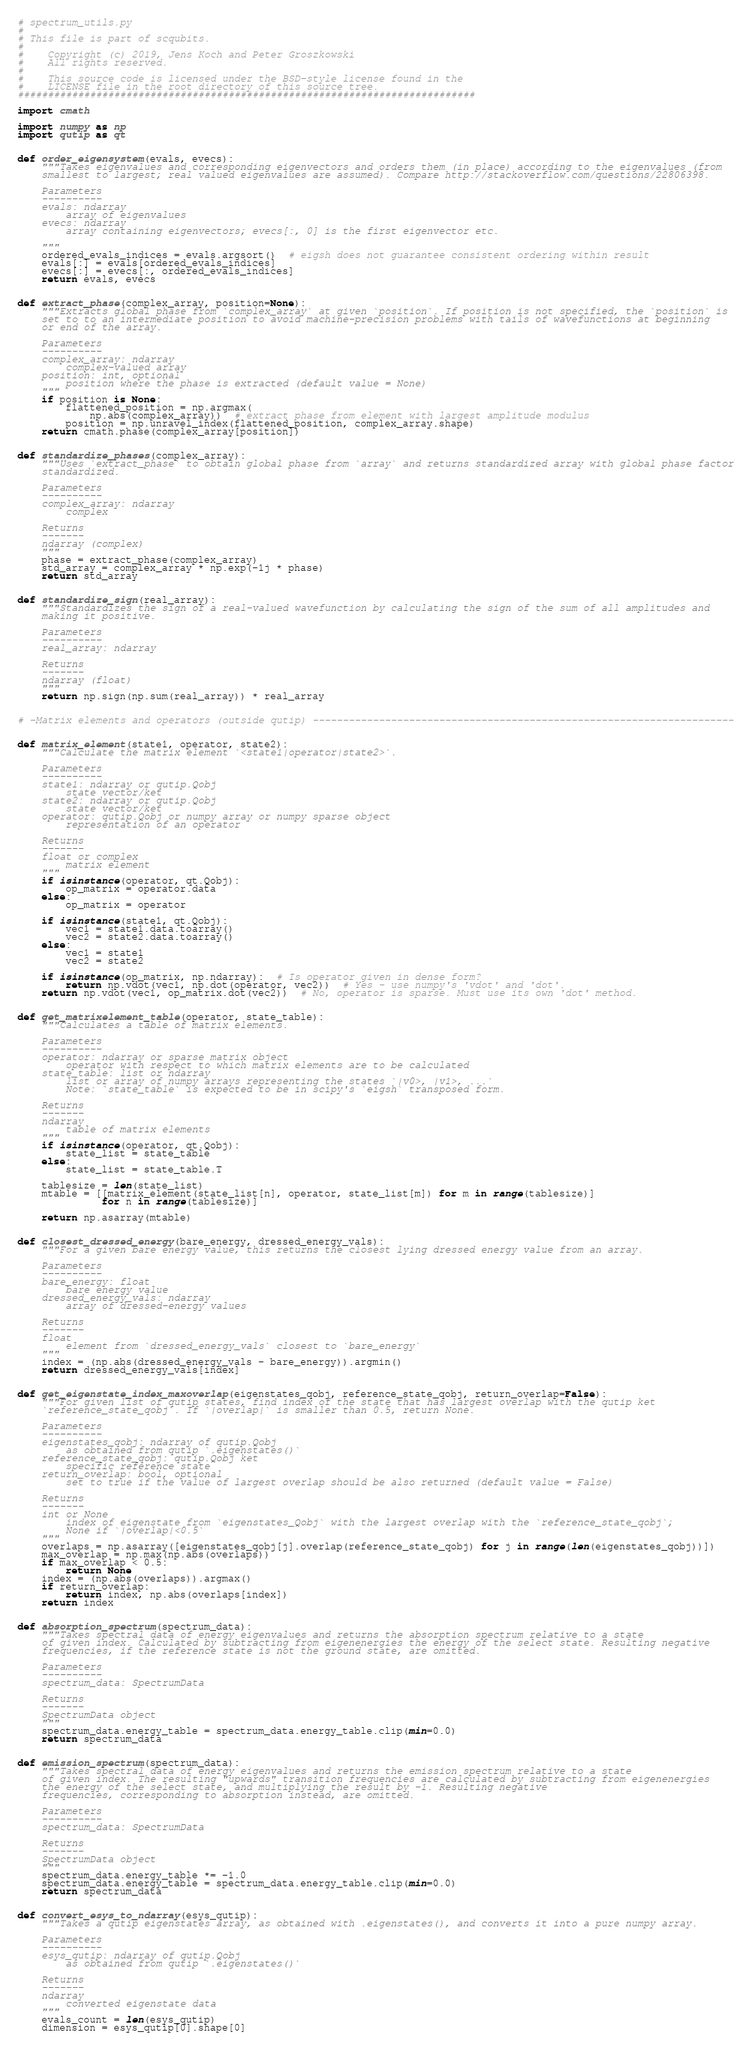<code> <loc_0><loc_0><loc_500><loc_500><_Python_># spectrum_utils.py
#
# This file is part of scqubits.
#
#    Copyright (c) 2019, Jens Koch and Peter Groszkowski
#    All rights reserved.
#
#    This source code is licensed under the BSD-style license found in the
#    LICENSE file in the root directory of this source tree.
############################################################################

import cmath

import numpy as np
import qutip as qt


def order_eigensystem(evals, evecs):
    """Takes eigenvalues and corresponding eigenvectors and orders them (in place) according to the eigenvalues (from
    smallest to largest; real valued eigenvalues are assumed). Compare http://stackoverflow.com/questions/22806398.

    Parameters
    ----------
    evals: ndarray
        array of eigenvalues
    evecs: ndarray
        array containing eigenvectors; evecs[:, 0] is the first eigenvector etc.

    """
    ordered_evals_indices = evals.argsort()  # eigsh does not guarantee consistent ordering within result
    evals[:] = evals[ordered_evals_indices]
    evecs[:] = evecs[:, ordered_evals_indices]
    return evals, evecs


def extract_phase(complex_array, position=None):
    """Extracts global phase from `complex_array` at given `position`. If position is not specified, the `position` is
    set to to an intermediate position to avoid machine-precision problems with tails of wavefunctions at beginning
    or end of the array.

    Parameters
    ----------
    complex_array: ndarray
        complex-valued array
    position: int, optional
        position where the phase is extracted (default value = None)
    """
    if position is None:
        flattened_position = np.argmax(
            np.abs(complex_array))  # extract phase from element with largest amplitude modulus
        position = np.unravel_index(flattened_position, complex_array.shape)
    return cmath.phase(complex_array[position])


def standardize_phases(complex_array):
    """Uses `extract_phase` to obtain global phase from `array` and returns standardized array with global phase factor
    standardized.

    Parameters
    ----------
    complex_array: ndarray
        complex

    Returns
    -------
    ndarray (complex)
    """
    phase = extract_phase(complex_array)
    std_array = complex_array * np.exp(-1j * phase)
    return std_array


def standardize_sign(real_array):
    """Standardizes the sign of a real-valued wavefunction by calculating the sign of the sum of all amplitudes and
    making it positive.

    Parameters
    ----------
    real_array: ndarray

    Returns
    -------
    ndarray (float)
    """
    return np.sign(np.sum(real_array)) * real_array


# -Matrix elements and operators (outside qutip) ----------------------------------------------------------------------


def matrix_element(state1, operator, state2):
    """Calculate the matrix element `<state1|operator|state2>`.

    Parameters
    ----------
    state1: ndarray or qutip.Qobj
        state vector/ket
    state2: ndarray or qutip.Qobj
        state vector/ket
    operator: qutip.Qobj or numpy array or numpy sparse object
        representation of an operator

    Returns
    -------
    float or complex
        matrix element
    """
    if isinstance(operator, qt.Qobj):
        op_matrix = operator.data
    else:
        op_matrix = operator

    if isinstance(state1, qt.Qobj):
        vec1 = state1.data.toarray()
        vec2 = state2.data.toarray()
    else:
        vec1 = state1
        vec2 = state2

    if isinstance(op_matrix, np.ndarray):  # Is operator given in dense form?
        return np.vdot(vec1, np.dot(operator, vec2))  # Yes - use numpy's 'vdot' and 'dot'.
    return np.vdot(vec1, op_matrix.dot(vec2))  # No, operator is sparse. Must use its own 'dot' method.


def get_matrixelement_table(operator, state_table):
    """Calculates a table of matrix elements.

    Parameters
    ----------
    operator: ndarray or sparse matrix object
        operator with respect to which matrix elements are to be calculated
    state_table: list or ndarray
        list or array of numpy arrays representing the states `|v0>, |v1>, ...`
        Note: `state_table` is expected to be in scipy's `eigsh` transposed form.

    Returns
    -------
    ndarray
        table of matrix elements
    """
    if isinstance(operator, qt.Qobj):
        state_list = state_table
    else:
        state_list = state_table.T

    tablesize = len(state_list)
    mtable = [[matrix_element(state_list[n], operator, state_list[m]) for m in range(tablesize)]
              for n in range(tablesize)]

    return np.asarray(mtable)


def closest_dressed_energy(bare_energy, dressed_energy_vals):
    """For a given bare energy value, this returns the closest lying dressed energy value from an array.

    Parameters
    ----------
    bare_energy: float
        bare energy value
    dressed_energy_vals: ndarray
        array of dressed-energy values

    Returns
    -------
    float
        element from `dressed_energy_vals` closest to `bare_energy`
    """
    index = (np.abs(dressed_energy_vals - bare_energy)).argmin()
    return dressed_energy_vals[index]


def get_eigenstate_index_maxoverlap(eigenstates_qobj, reference_state_qobj, return_overlap=False):
    """For given list of qutip states, find index of the state that has largest overlap with the qutip ket
    `reference_state_qobj`. If `|overlap|` is smaller than 0.5, return None.

    Parameters
    ----------
    eigenstates_qobj: ndarray of qutip.Qobj
        as obtained from qutip `.eigenstates()`
    reference_state_qobj: qutip.Qobj ket
        specific reference state
    return_overlap: bool, optional
        set to true if the value of largest overlap should be also returned (default value = False)

    Returns
    -------
    int or None
        index of eigenstate from `eigenstates_Qobj` with the largest overlap with the `reference_state_qobj`;
        None if `|overlap|<0.5`
    """
    overlaps = np.asarray([eigenstates_qobj[j].overlap(reference_state_qobj) for j in range(len(eigenstates_qobj))])
    max_overlap = np.max(np.abs(overlaps))
    if max_overlap < 0.5:
        return None
    index = (np.abs(overlaps)).argmax()
    if return_overlap:
        return index, np.abs(overlaps[index])
    return index


def absorption_spectrum(spectrum_data):
    """Takes spectral data of energy eigenvalues and returns the absorption spectrum relative to a state
    of given index. Calculated by subtracting from eigenenergies the energy of the select state. Resulting negative
    frequencies, if the reference state is not the ground state, are omitted.

    Parameters
    ----------
    spectrum_data: SpectrumData

    Returns
    -------
    SpectrumData object
    """
    spectrum_data.energy_table = spectrum_data.energy_table.clip(min=0.0)
    return spectrum_data


def emission_spectrum(spectrum_data):
    """Takes spectral data of energy eigenvalues and returns the emission spectrum relative to a state
    of given index. The resulting "upwards" transition frequencies are calculated by subtracting from eigenenergies
    the energy of the select state, and multiplying the result by -1. Resulting negative
    frequencies, corresponding to absorption instead, are omitted.

    Parameters
    ----------
    spectrum_data: SpectrumData

    Returns
    -------
    SpectrumData object
    """
    spectrum_data.energy_table *= -1.0
    spectrum_data.energy_table = spectrum_data.energy_table.clip(min=0.0)
    return spectrum_data


def convert_esys_to_ndarray(esys_qutip):
    """Takes a qutip eigenstates array, as obtained with .eigenstates(), and converts it into a pure numpy array.

    Parameters
    ----------
    esys_qutip: ndarray of qutip.Qobj
        as obtained from qutip `.eigenstates()`

    Returns
    -------
    ndarray
        converted eigenstate data
    """
    evals_count = len(esys_qutip)
    dimension = esys_qutip[0].shape[0]</code> 